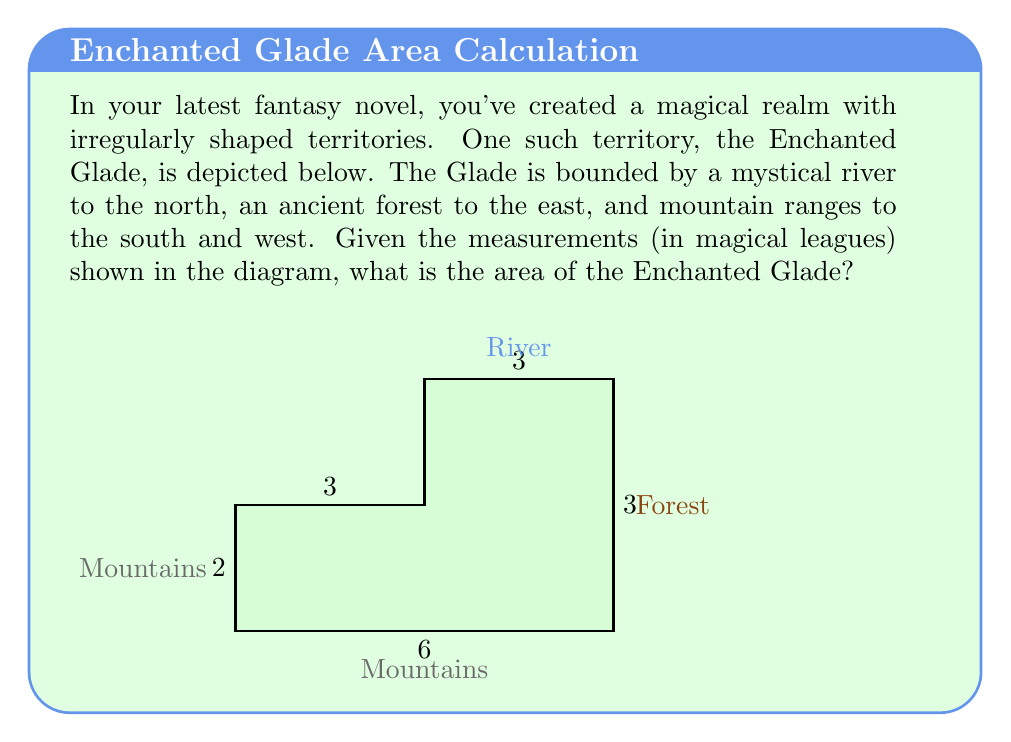Give your solution to this math problem. To find the area of this irregularly shaped territory, we can break it down into simpler geometric shapes and sum their areas. Let's approach this step-by-step:

1) The Enchanted Glade can be divided into two rectangles:
   - A larger rectangle at the bottom
   - A smaller rectangle at the top-right

2) For the larger rectangle:
   - Width = 6 leagues
   - Height = 2 leagues
   - Area = $6 \times 2 = 12$ square leagues

3) For the smaller rectangle:
   - Width = 3 leagues
   - Height = 2 leagues (4 - 2 = 2)
   - Area = $3 \times 2 = 6$ square leagues

4) The total area is the sum of these two rectangles:
   $$\text{Total Area} = 12 + 6 = 18 \text{ square leagues}$$

Therefore, the area of the Enchanted Glade is 18 square magical leagues.
Answer: 18 square magical leagues 